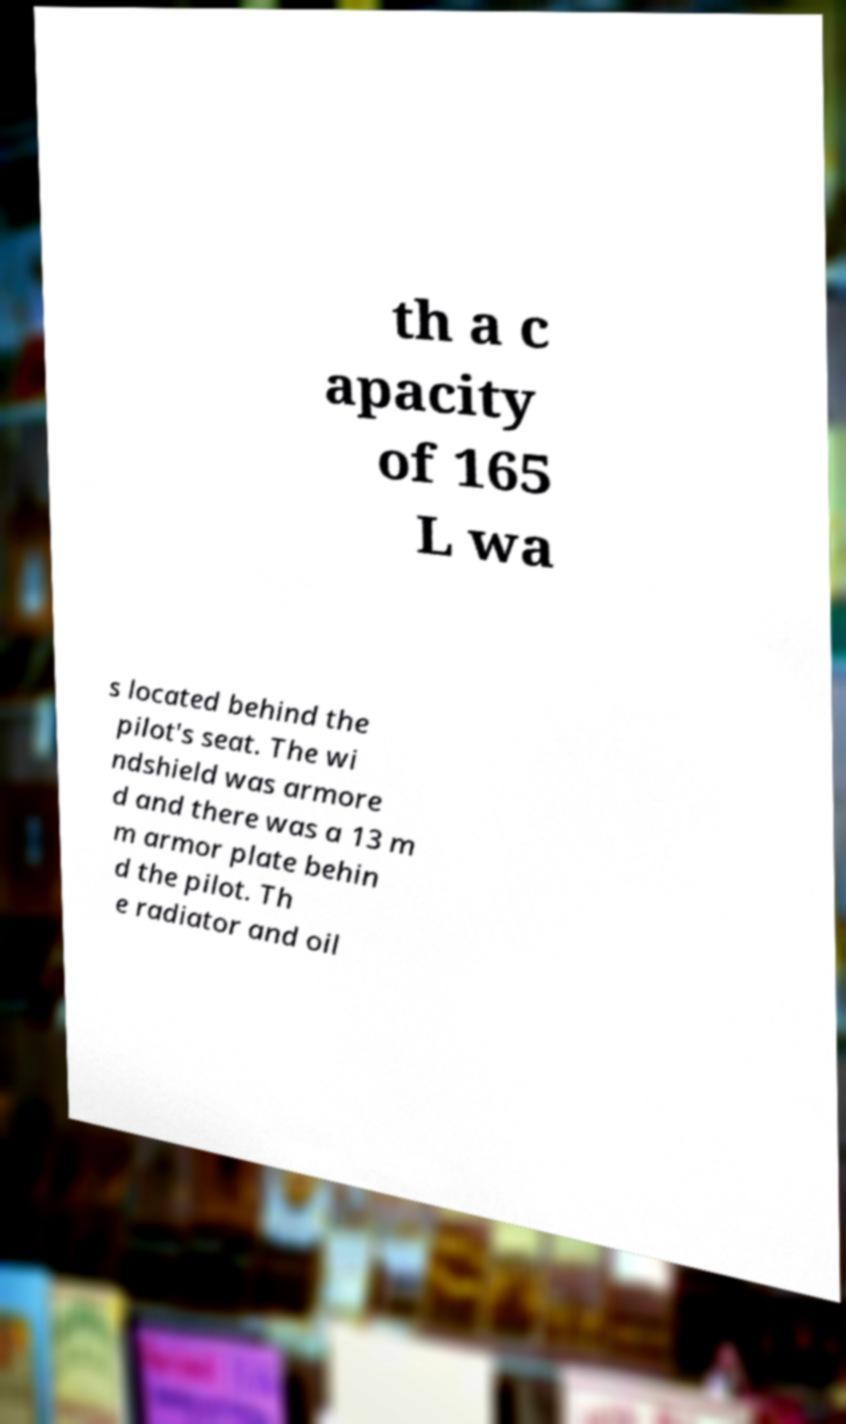What messages or text are displayed in this image? I need them in a readable, typed format. th a c apacity of 165 L wa s located behind the pilot's seat. The wi ndshield was armore d and there was a 13 m m armor plate behin d the pilot. Th e radiator and oil 